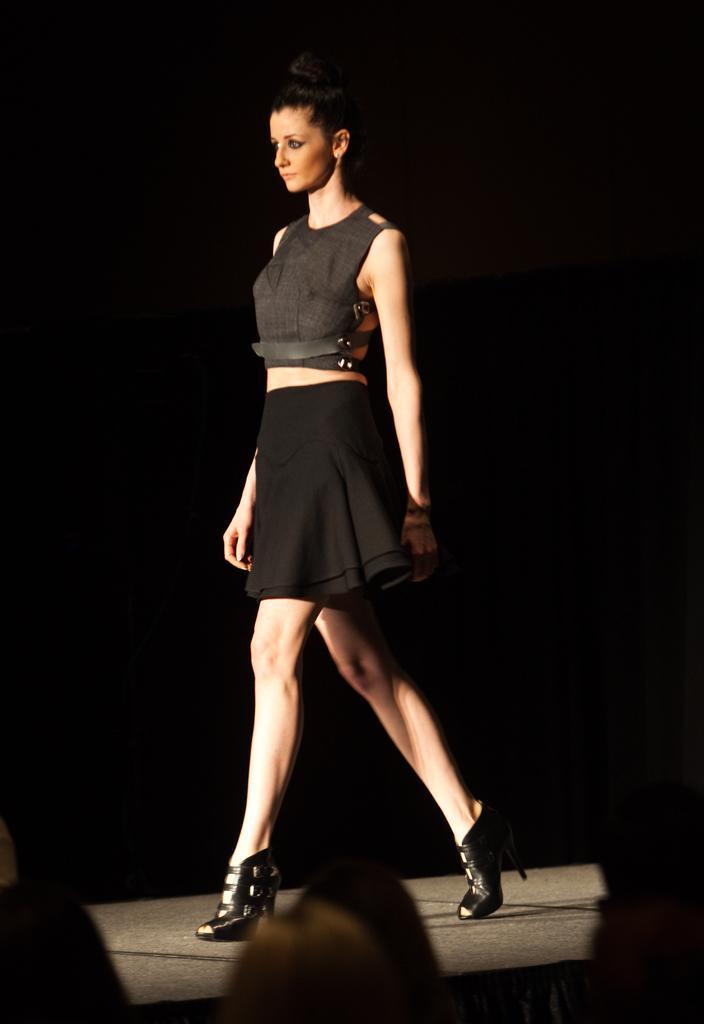Can you describe this image briefly? In this picture there is a woman walking. In the background of the image it is dark. At the bottom of the image we can see heads of people. 